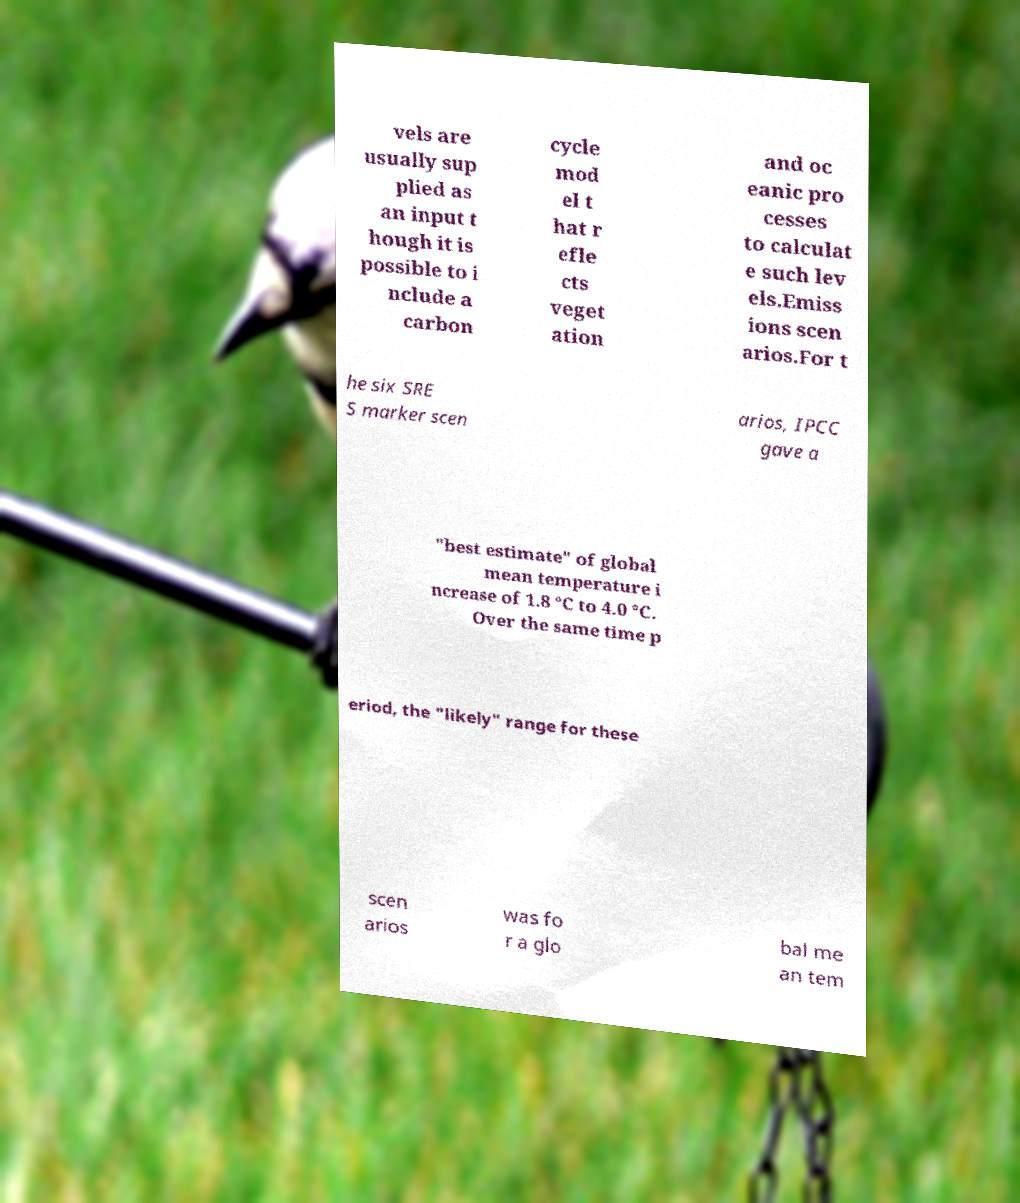There's text embedded in this image that I need extracted. Can you transcribe it verbatim? vels are usually sup plied as an input t hough it is possible to i nclude a carbon cycle mod el t hat r efle cts veget ation and oc eanic pro cesses to calculat e such lev els.Emiss ions scen arios.For t he six SRE S marker scen arios, IPCC gave a "best estimate" of global mean temperature i ncrease of 1.8 °C to 4.0 °C. Over the same time p eriod, the "likely" range for these scen arios was fo r a glo bal me an tem 